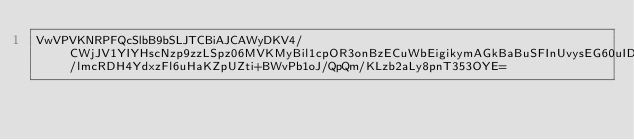Convert code to text. <code><loc_0><loc_0><loc_500><loc_500><_SML_>VwVPVKNRPFQcSlbB9bSLJTCBiAJCAWyDKV4/CWjJV1YIYHscNzp9zzLSpz06MVKMyBil1cpOR3onBzECuWbEigikymAGkBaBuSFInUvysEG60uIDbqevAkIAiXwjX3W59CO3rWYuJzmp3sBcJir37/lmcRDH4YdxzFl6uHaKZpUZti+BWvPb1oJ/QpQm/KLzb2aLy8pnT353OYE=</code> 